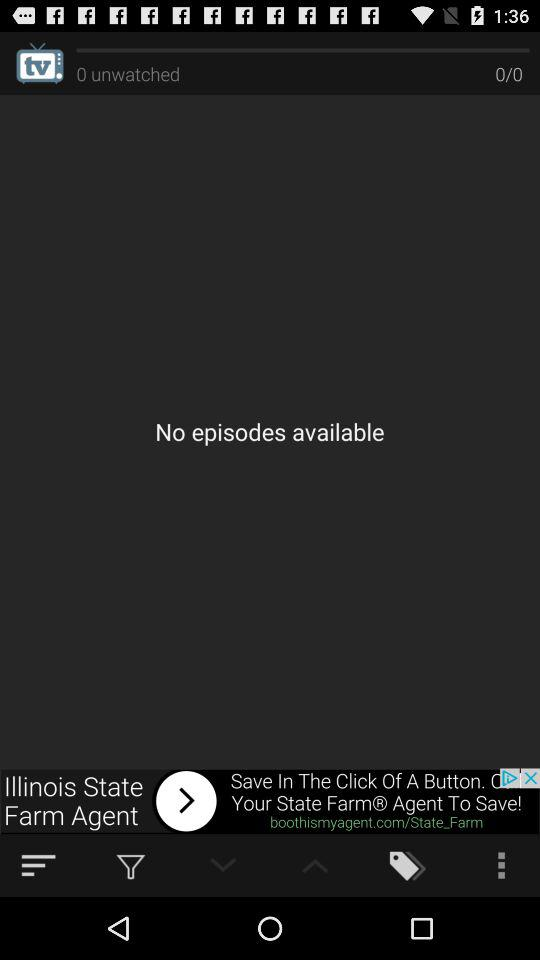What is the number of unwatched episodes? The number of unwatched episodes is 0. 